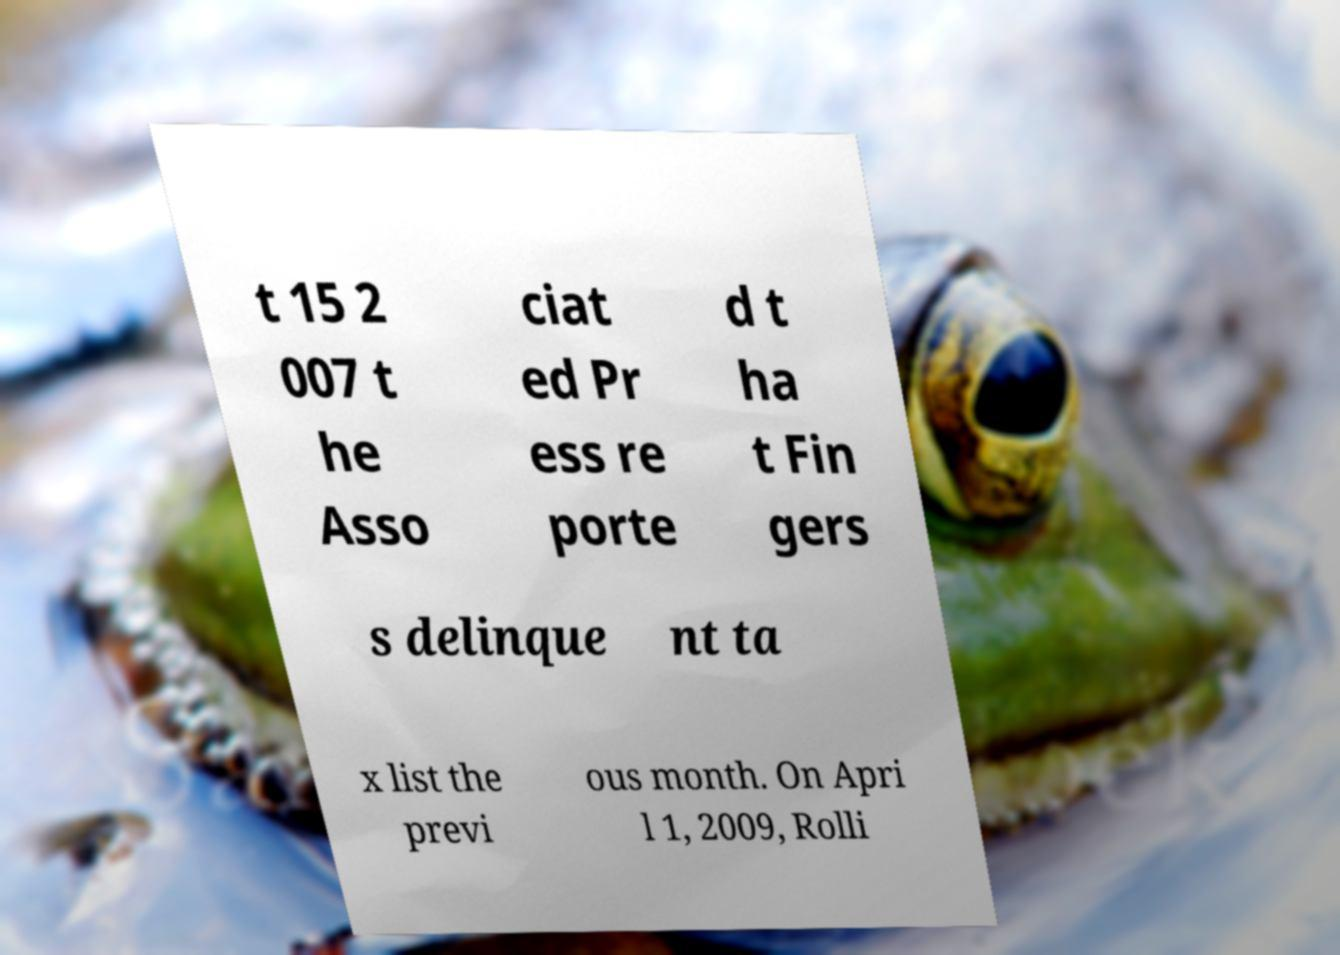Could you extract and type out the text from this image? t 15 2 007 t he Asso ciat ed Pr ess re porte d t ha t Fin gers s delinque nt ta x list the previ ous month. On Apri l 1, 2009, Rolli 